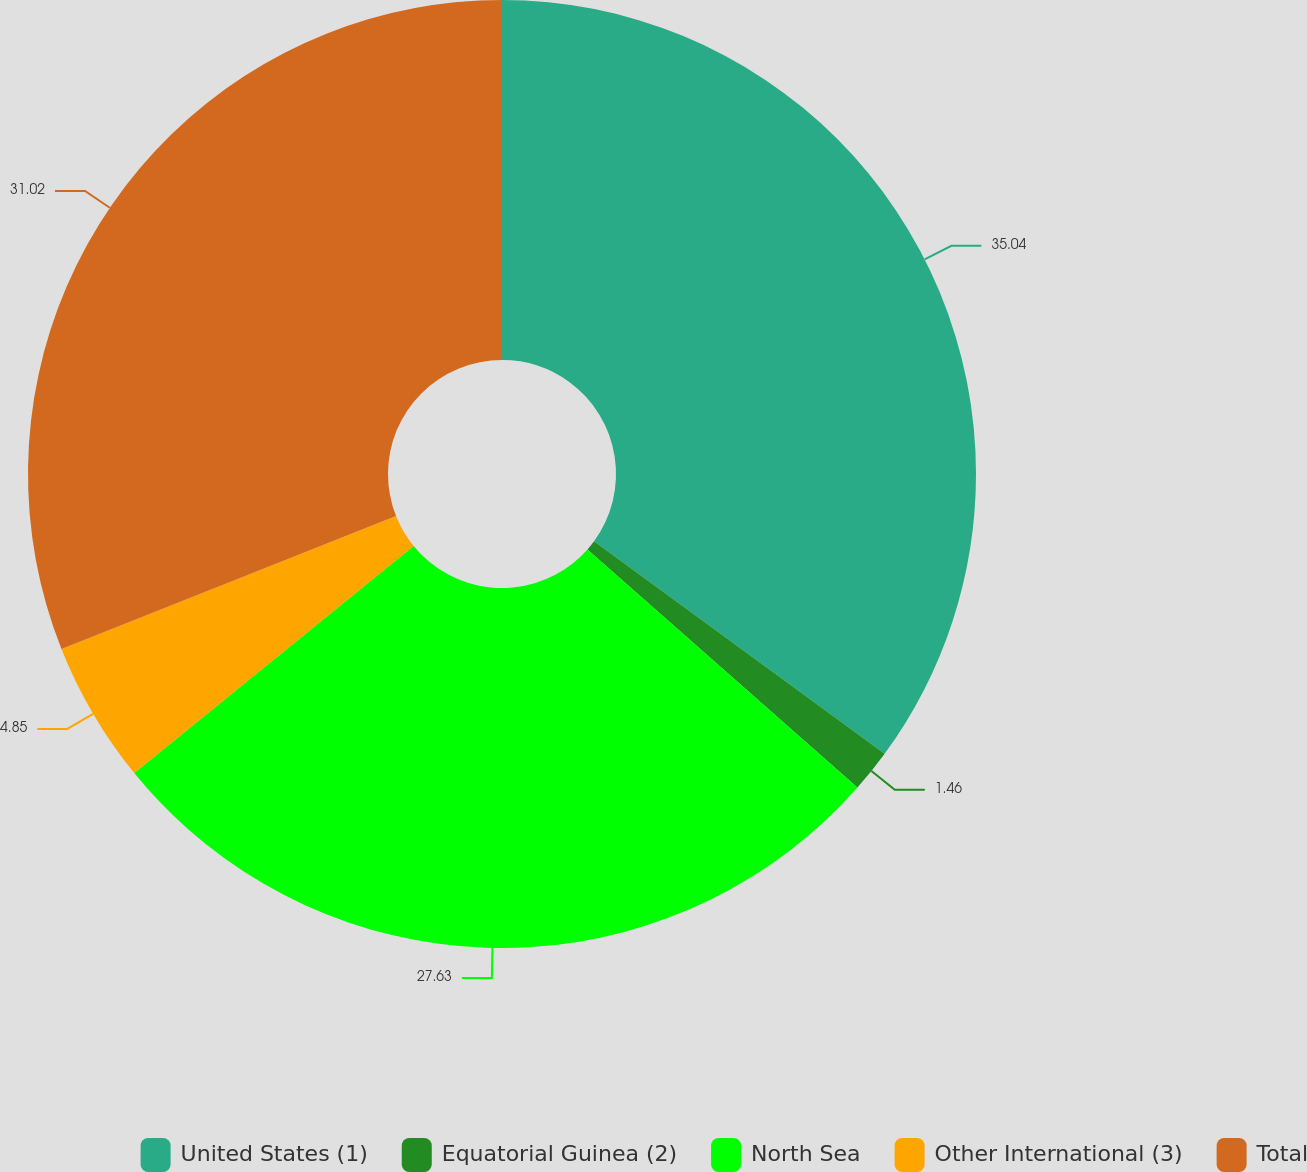Convert chart to OTSL. <chart><loc_0><loc_0><loc_500><loc_500><pie_chart><fcel>United States (1)<fcel>Equatorial Guinea (2)<fcel>North Sea<fcel>Other International (3)<fcel>Total<nl><fcel>35.05%<fcel>1.46%<fcel>27.63%<fcel>4.85%<fcel>31.02%<nl></chart> 